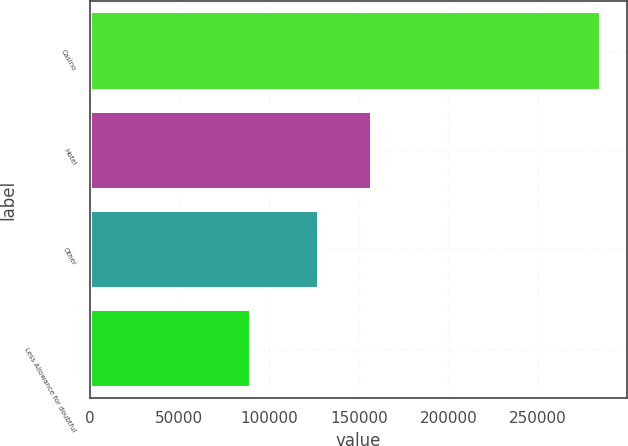<chart> <loc_0><loc_0><loc_500><loc_500><bar_chart><fcel>Casino<fcel>Hotel<fcel>Other<fcel>Less Allowance for doubtful<nl><fcel>285182<fcel>157489<fcel>127677<fcel>89789<nl></chart> 